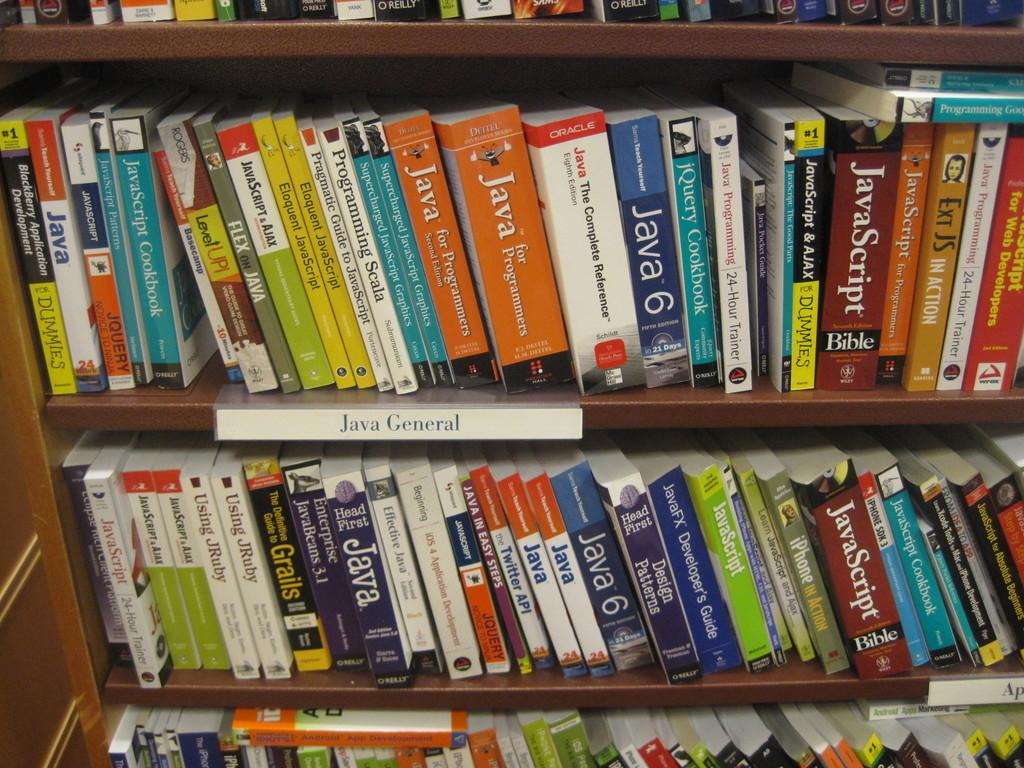What type of objects can be seen in the image? There are many colorful books in the image. Where are the books located? The books are in wooden shelves. What type of ball is being used for pleasure in the image? There is no ball present in the image; it features many colorful books in wooden shelves. 